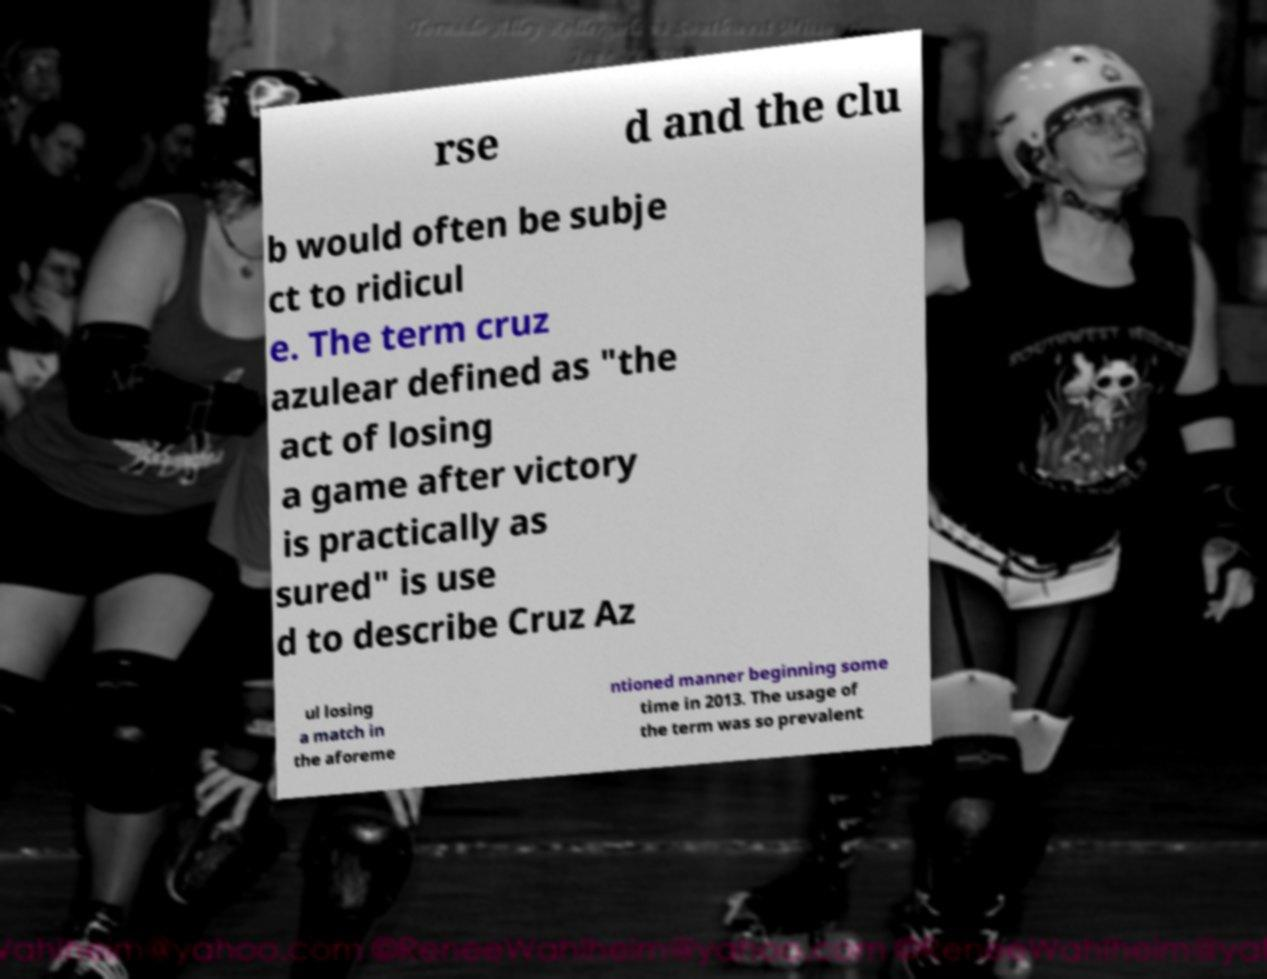Could you assist in decoding the text presented in this image and type it out clearly? rse d and the clu b would often be subje ct to ridicul e. The term cruz azulear defined as "the act of losing a game after victory is practically as sured" is use d to describe Cruz Az ul losing a match in the aforeme ntioned manner beginning some time in 2013. The usage of the term was so prevalent 